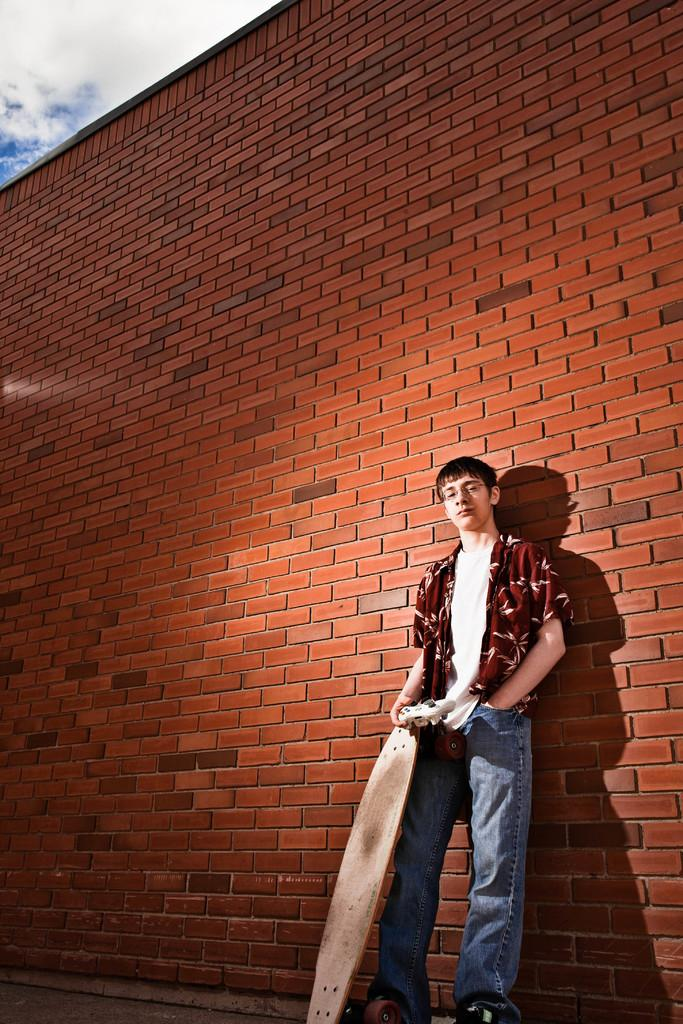Who is in the image? There is a man in the image. What is the man doing in the image? The man is standing beside a wall and holding a skateboard. What can be seen in the background of the image? The sky is visible in the image. How would you describe the weather based on the sky in the image? The sky looks cloudy in the image. What type of plants can be seen growing on the man's skateboard in the image? There are no plants visible on the man's skateboard in the image. 